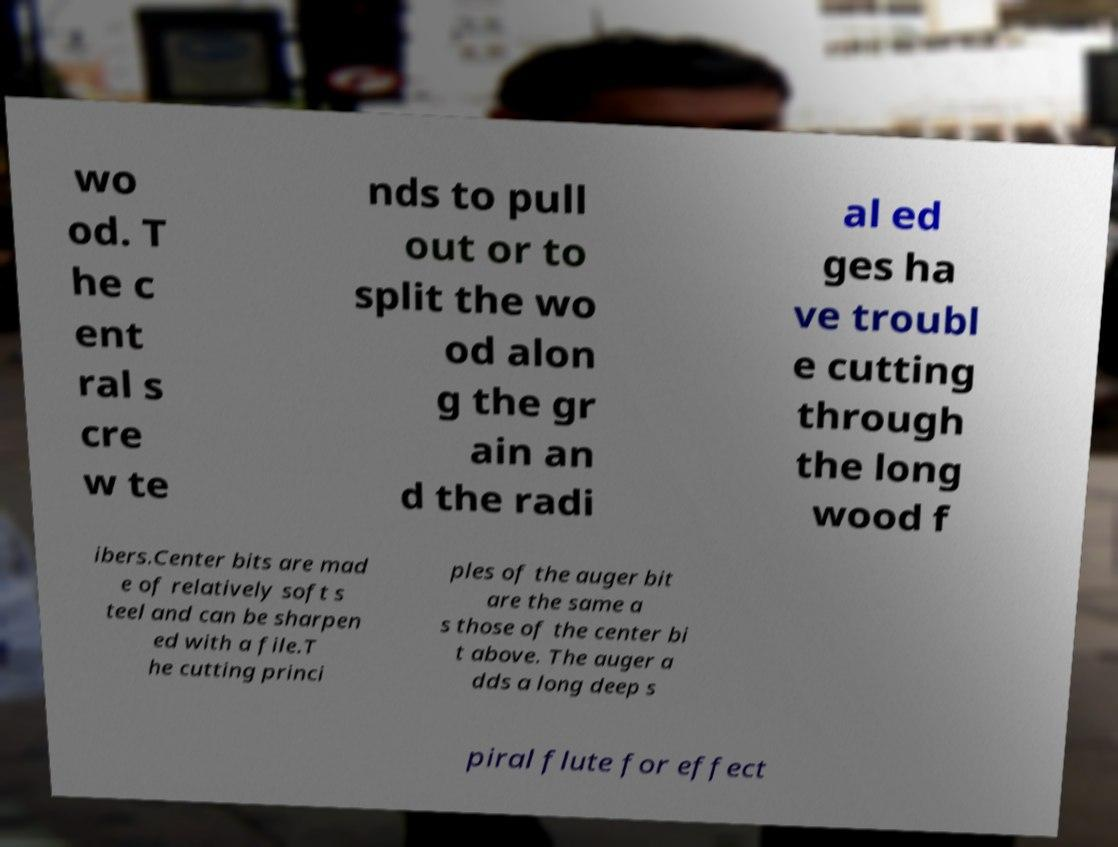For documentation purposes, I need the text within this image transcribed. Could you provide that? wo od. T he c ent ral s cre w te nds to pull out or to split the wo od alon g the gr ain an d the radi al ed ges ha ve troubl e cutting through the long wood f ibers.Center bits are mad e of relatively soft s teel and can be sharpen ed with a file.T he cutting princi ples of the auger bit are the same a s those of the center bi t above. The auger a dds a long deep s piral flute for effect 